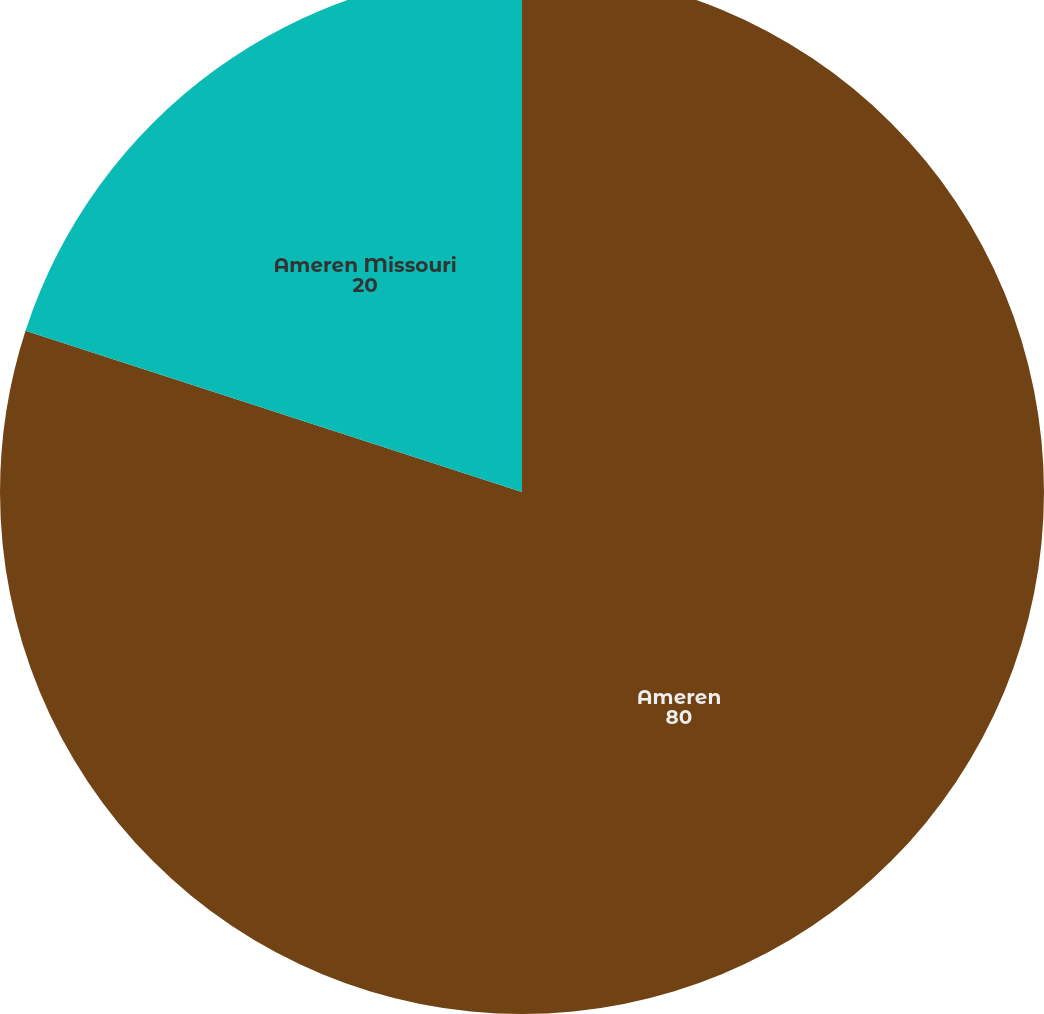Convert chart to OTSL. <chart><loc_0><loc_0><loc_500><loc_500><pie_chart><fcel>Ameren<fcel>Ameren Missouri<nl><fcel>80.0%<fcel>20.0%<nl></chart> 